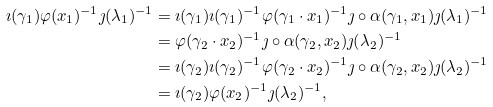Convert formula to latex. <formula><loc_0><loc_0><loc_500><loc_500>\imath ( \gamma _ { 1 } ) \varphi ( x _ { 1 } ) ^ { - 1 } \jmath ( \lambda _ { 1 } ) ^ { - 1 } & = \imath ( \gamma _ { 1 } ) \imath ( \gamma _ { 1 } ) ^ { - 1 } \varphi ( \gamma _ { 1 } \cdot x _ { 1 } ) ^ { - 1 } \jmath \circ \alpha ( \gamma _ { 1 } , x _ { 1 } ) \jmath ( \lambda _ { 1 } ) ^ { - 1 } \\ & = \varphi ( \gamma _ { 2 } \cdot x _ { 2 } ) ^ { - 1 } \jmath \circ \alpha ( \gamma _ { 2 } , x _ { 2 } ) \jmath ( \lambda _ { 2 } ) ^ { - 1 } \\ & = \imath ( \gamma _ { 2 } ) \imath ( \gamma _ { 2 } ) ^ { - 1 } \varphi ( \gamma _ { 2 } \cdot x _ { 2 } ) ^ { - 1 } \jmath \circ \alpha ( \gamma _ { 2 } , x _ { 2 } ) \jmath ( \lambda _ { 2 } ) ^ { - 1 } \\ & = \imath ( \gamma _ { 2 } ) \varphi ( x _ { 2 } ) ^ { - 1 } \jmath ( \lambda _ { 2 } ) ^ { - 1 } ,</formula> 